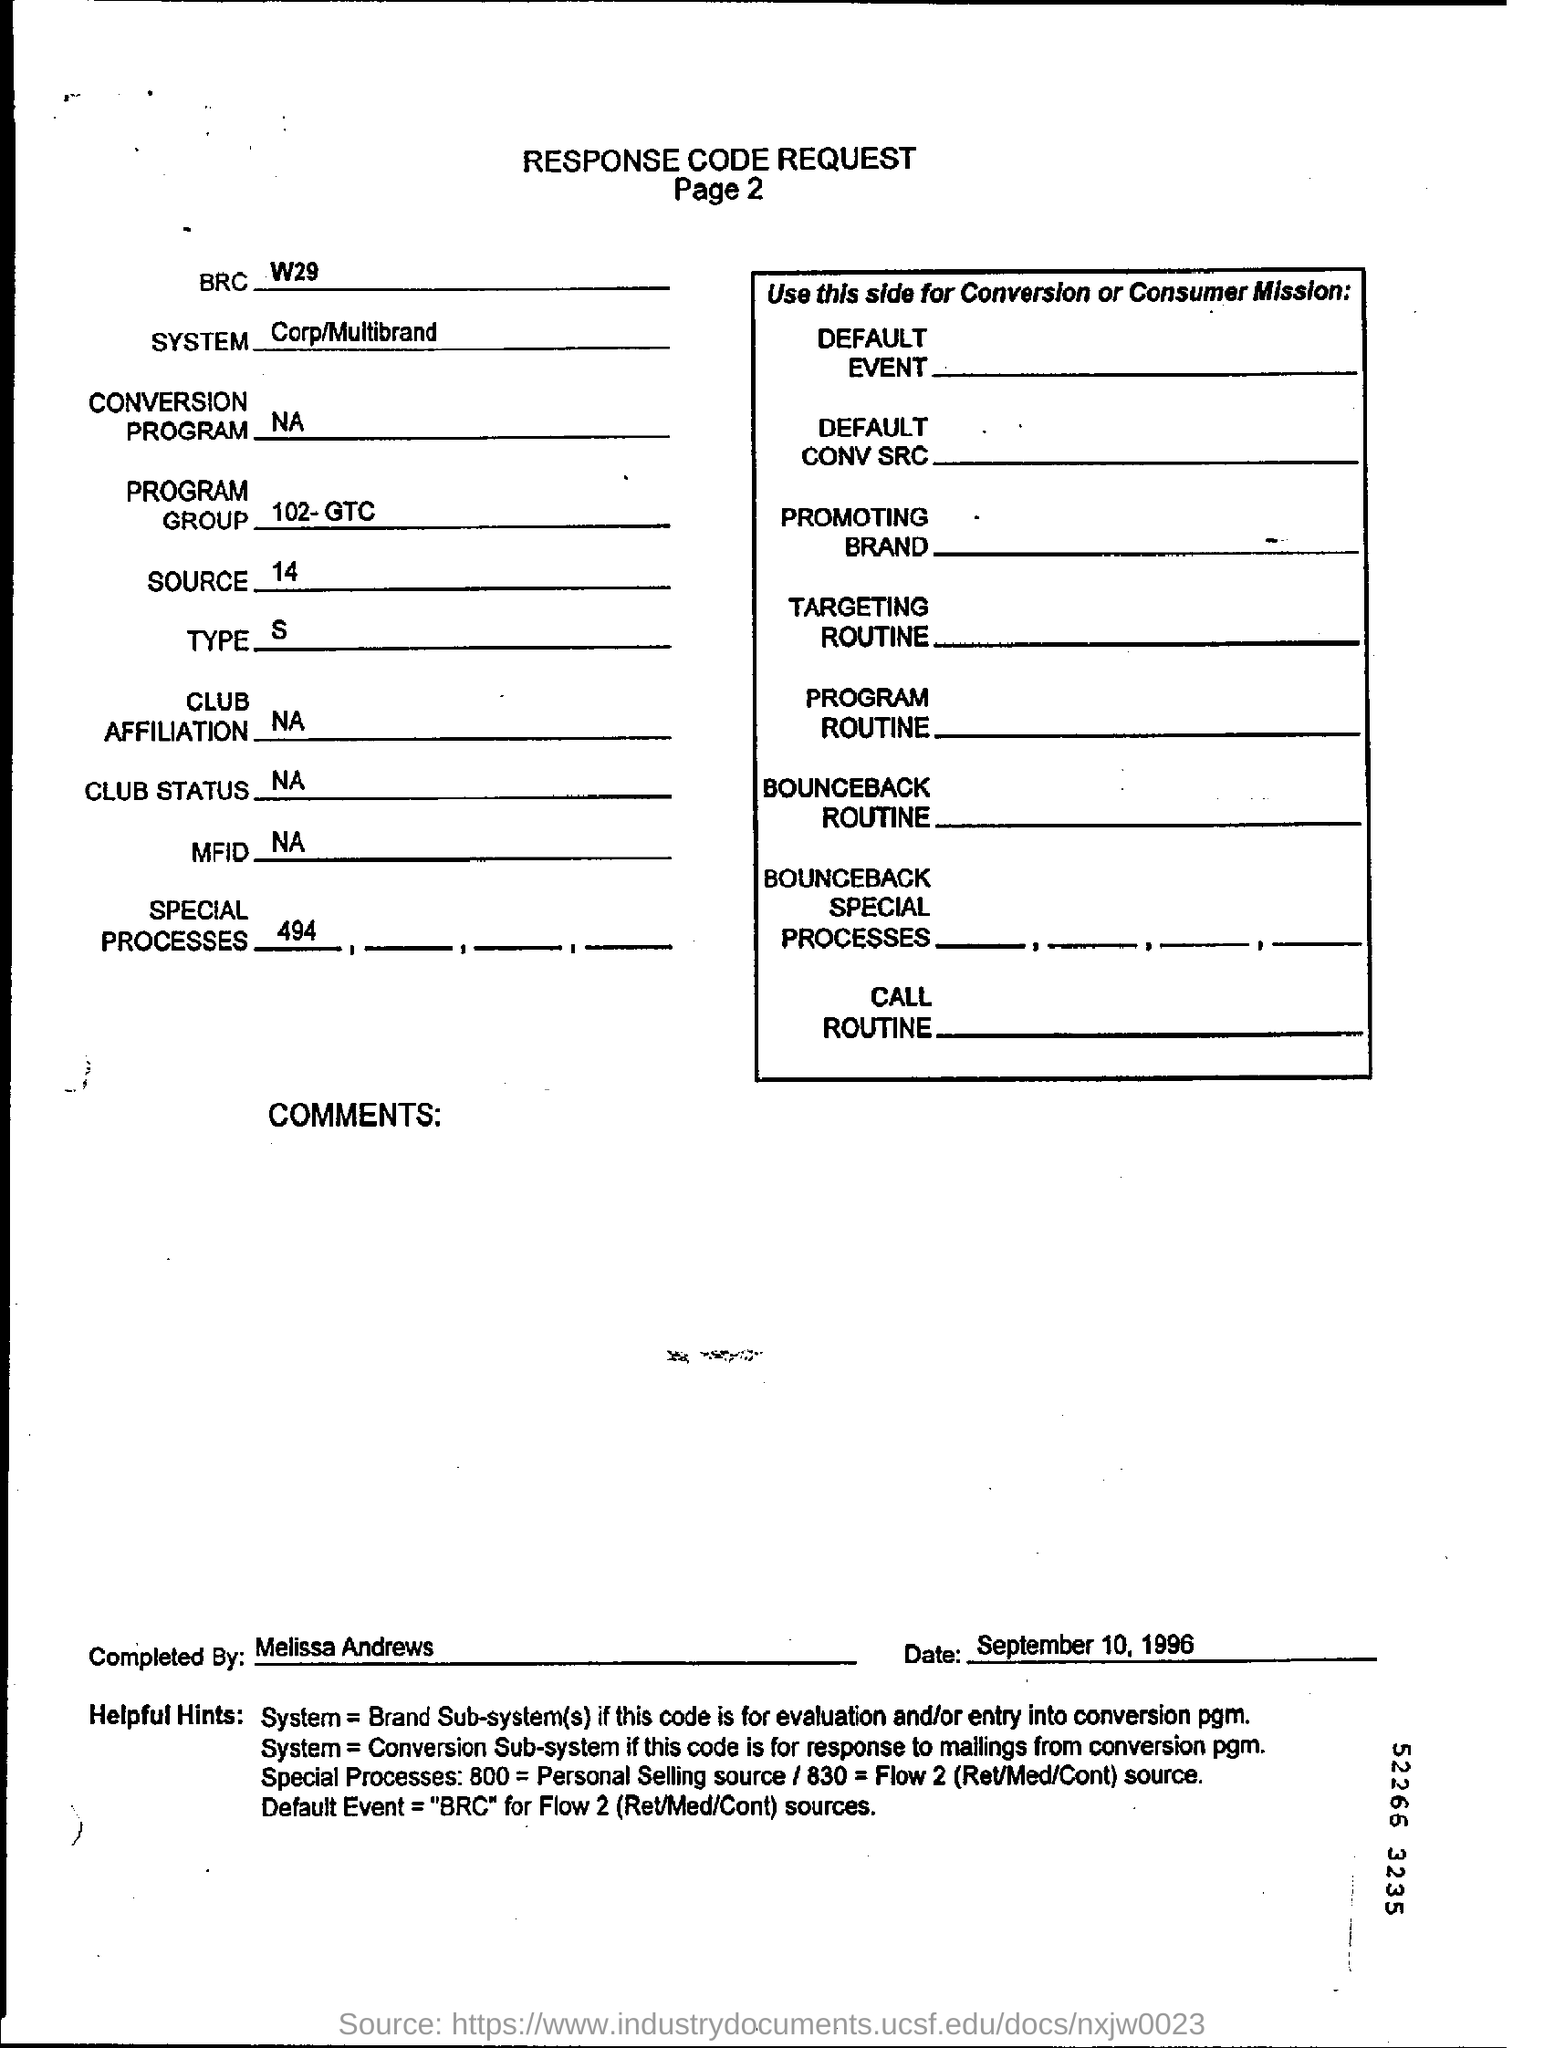Point out several critical features in this image. The system specified in the request form is the Corp/Multibrand system. Melissa Andrews completed the Request. 